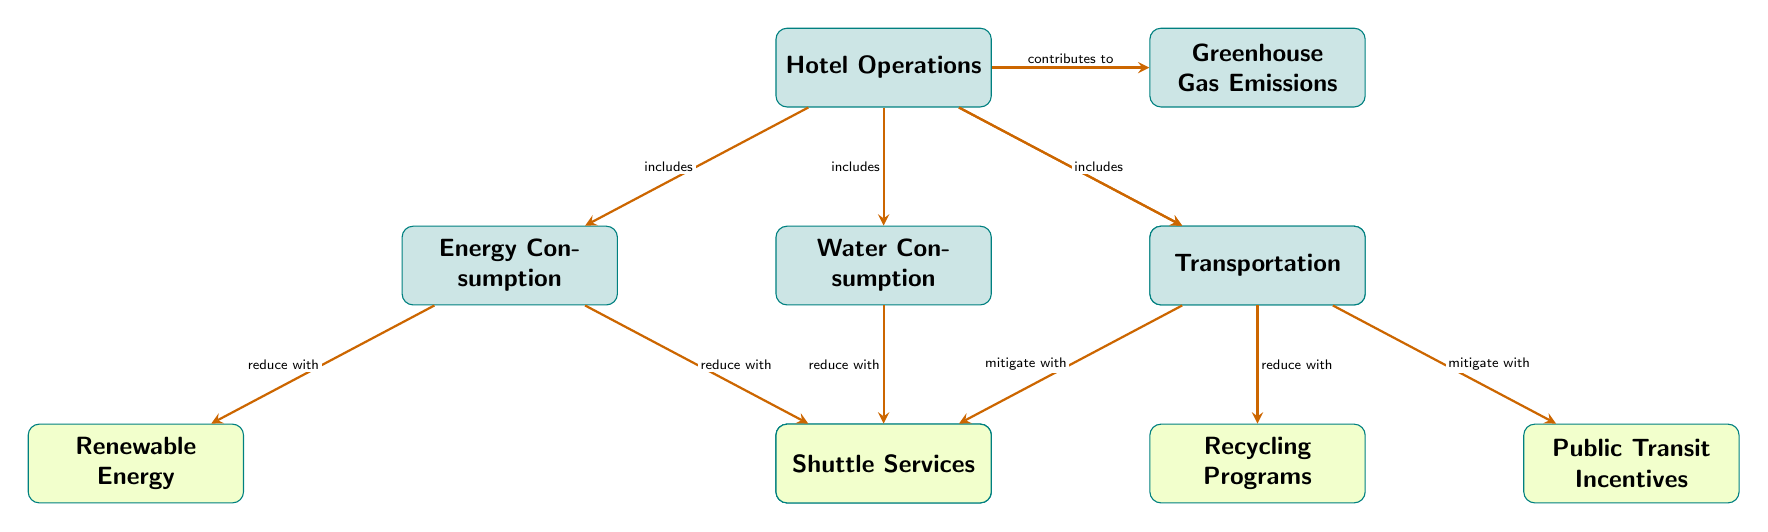What is the main focus of hotel operations in the diagram? The main focus of hotel operations is represented by the node labeled "Hotel Operations" which is linked to various components contributing to greenhouse gas emissions.
Answer: Hotel Operations What are the two components contributing to greenhouse gas emissions listed under energy consumption? The components under energy consumption are "Renewable Energy" and "Energy-efficient Lighting." They are the strategies connected to the energy consumption node that aim to reduce emissions.
Answer: Renewable Energy, Energy-efficient Lighting How many strategies for reducing emissions are associated with water consumption? There is one strategy for reducing emissions associated with water consumption, which is "Water-saving Fixtures." This can be found directly linked below the water consumption node.
Answer: 1 What type of strategies are connected to waste management? The strategy connected to waste management is "Recycling Programs," which aims to reduce the impact of waste management on greenhouse gas emissions.
Answer: Recycling Programs Which component indicates a mitigation strategy related to transportation? The mitigation strategies related to transportation are "Shuttle Services" and "Public Transit Incentives," as they are designed to mitigate greenhouse gas emissions from the transportation sector.
Answer: Shuttle Services, Public Transit Incentives How many total components contribute to greenhouse gas emissions according to the diagram? There are five components contributing to greenhouse gas emissions: Energy Consumption, Water Consumption, Waste Management, and Transportation, which are all linked to the hotel operations node.
Answer: 5 Which two types of consumption are part of hotel operations that directly influence emissions? The two types of consumption that influence emissions are "Energy Consumption" and "Water Consumption," both directly connected to hotel operations.
Answer: Energy Consumption, Water Consumption What is the relationship shown between hotel operations and greenhouse gas emissions? The relationship shown is that hotel operations contribute to greenhouse gas emissions, as indicated by the directed arrow from the hotel operations node to the greenhouse gas emissions node.
Answer: Contributes to 